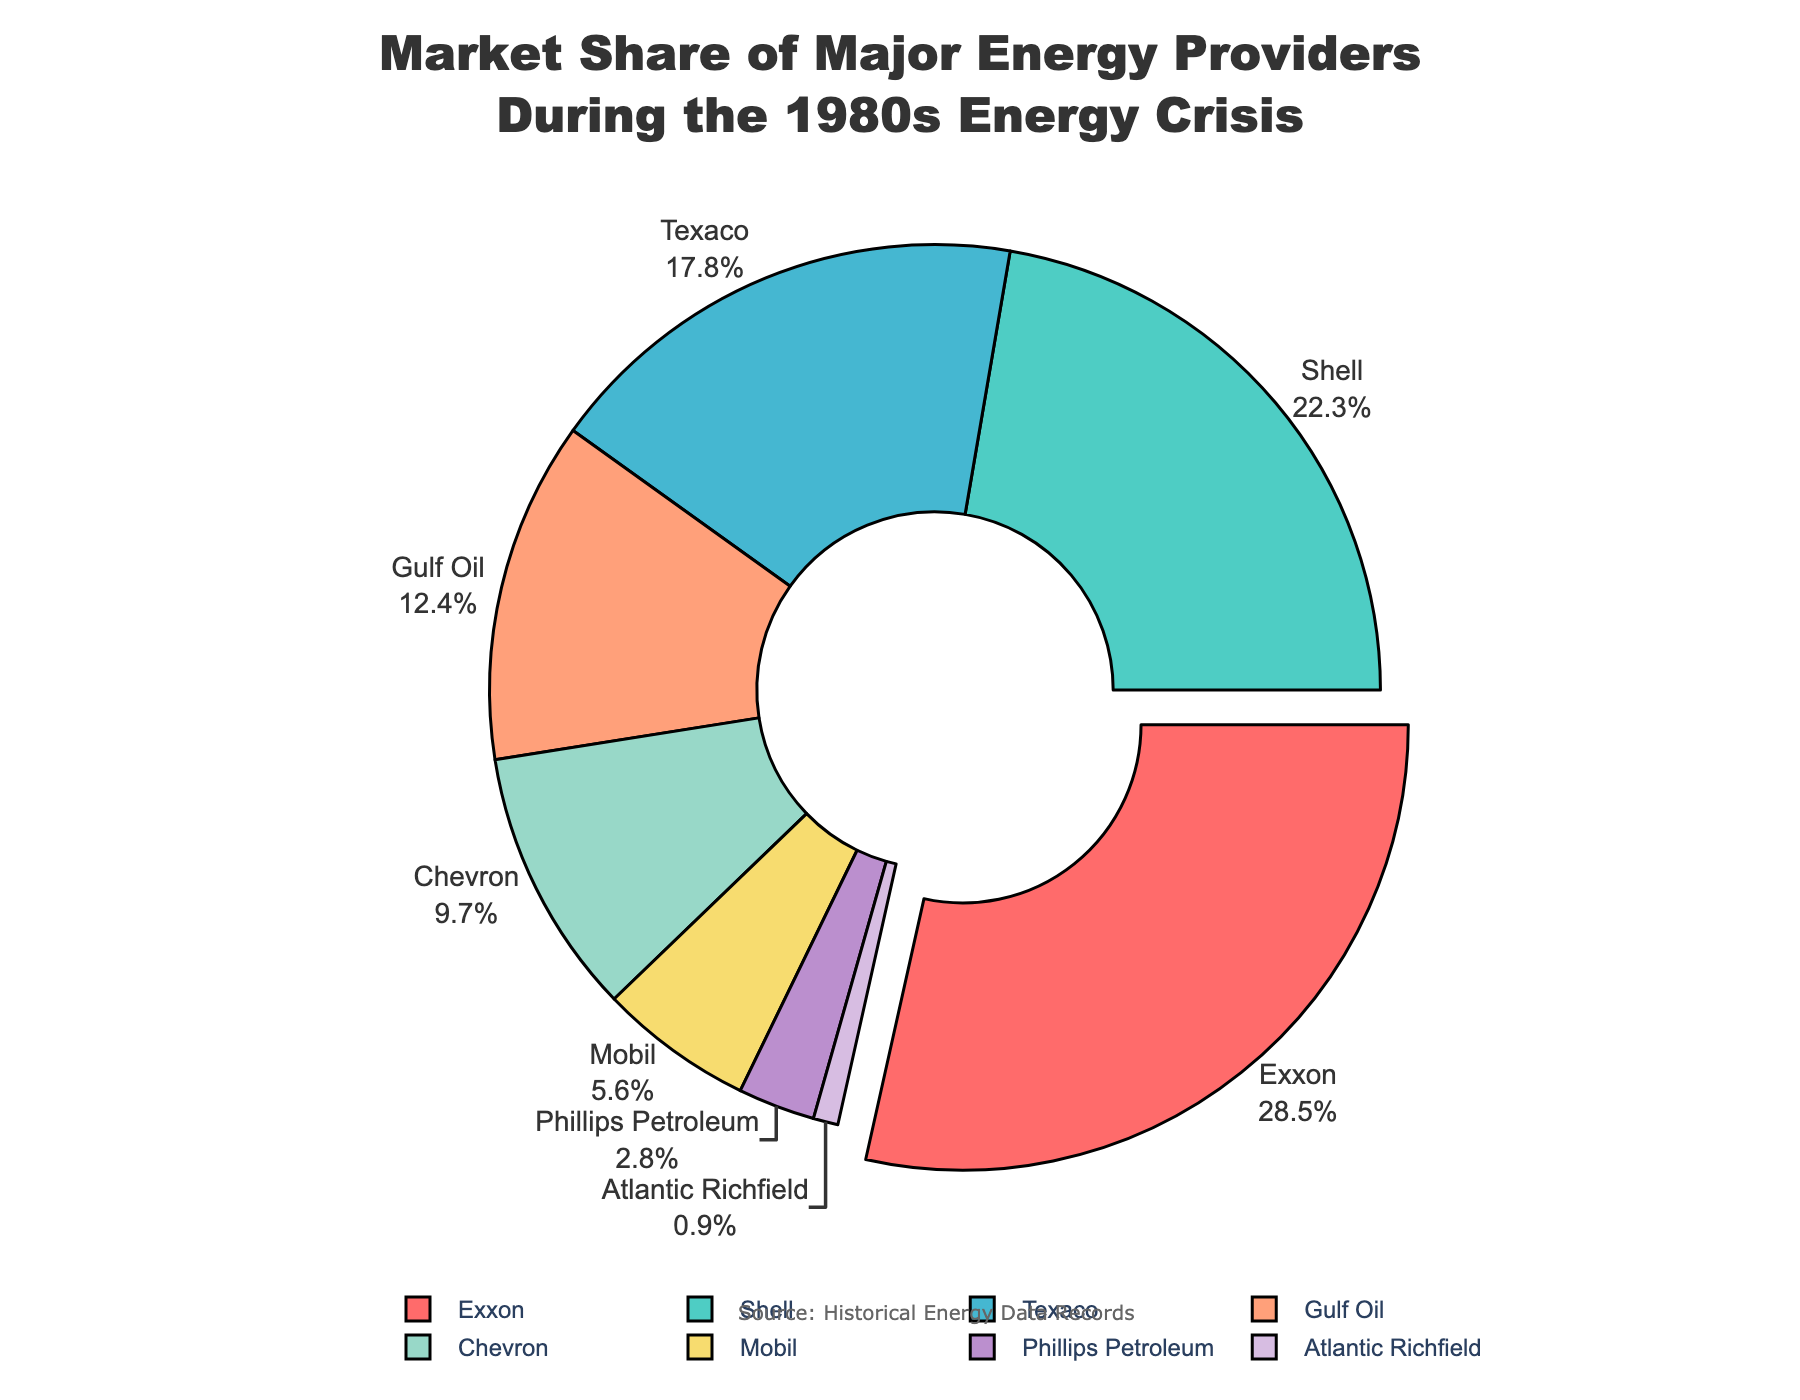What is the market share of Exxon? Exxon holds the largest portion of the market. According to the pie chart, Exxon's share is 28.5%.
Answer: 28.5% Which company has the second largest market share? By comparing the size of the slices, Shell has the second largest slice, indicating it has the second highest market share at 22.3%.
Answer: Shell How does Texaco's market share compare to Chevron's? Texaco's share is visibly larger than Chevron's. Texaco has a market share of 17.8%, while Chevron has 9.7%.
Answer: Texaco has a larger market share What is the combined market share of Gulf Oil and Mobil? Gulf Oil has a market share of 12.4% and Mobil has 5.6%. Adding these together: 12.4% + 5.6% = 18%.
Answer: 18% Which company has the smallest market share and what is its value? The smallest slice of the pie chart belongs to Atlantic Richfield, which holds a market share of 0.9%.
Answer: Atlantic Richfield with 0.9% What is the difference in market share between Exxon and Shell? Exxon’s market share is 28.5% and Shell’s is 22.3%. The difference is 28.5% - 22.3% = 6.2%.
Answer: 6.2% What is the sum of market shares of the top three companies (Exxon, Shell, Texaco)? Adding the market shares of Exxon (28.5%), Shell (22.3%), and Texaco (17.8%): 28.5% + 22.3% + 17.8% = 68.6%.
Answer: 68.6% Which company is represented by the light green color in the pie chart? By referring to the color distribution, the company represented by light green is Shell.
Answer: Shell How does the combined market share of Chevron and Phillips Petroleum compare to Texaco? The combined market share of Chevron (9.7%) and Phillips Petroleum (2.8%) is 9.7% + 2.8% = 12.5%. Comparing this to Texaco’s 17.8%, Texaco has a higher market share.
Answer: Texaco has a higher market share Which company slice appears to be pulled out from the pie chart and why? The pie slice representing Exxon is pulled out, likely to emphasize it as having the largest market share at 28.5%.
Answer: Exxon 